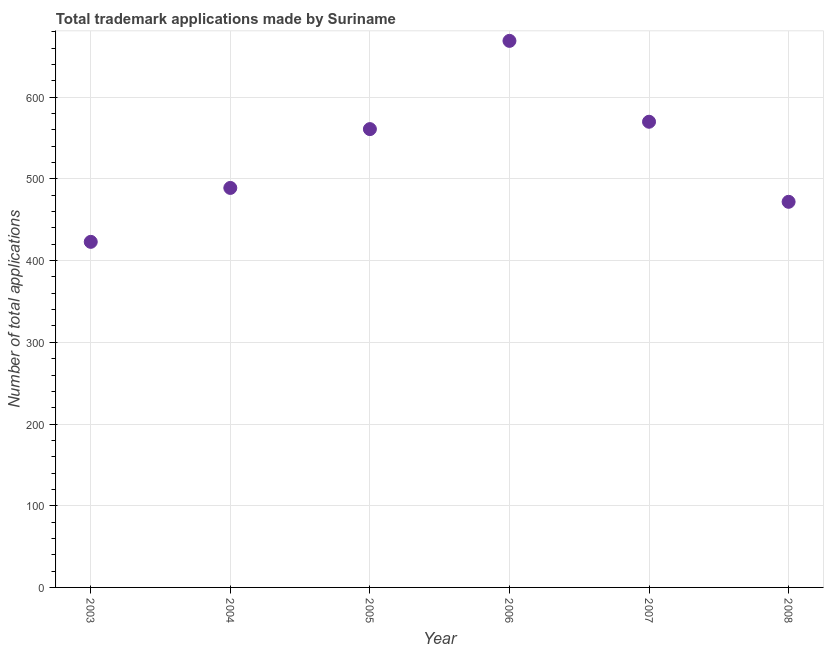What is the number of trademark applications in 2003?
Provide a succinct answer. 423. Across all years, what is the maximum number of trademark applications?
Provide a short and direct response. 669. Across all years, what is the minimum number of trademark applications?
Offer a very short reply. 423. In which year was the number of trademark applications minimum?
Give a very brief answer. 2003. What is the sum of the number of trademark applications?
Ensure brevity in your answer.  3184. What is the difference between the number of trademark applications in 2003 and 2004?
Ensure brevity in your answer.  -66. What is the average number of trademark applications per year?
Give a very brief answer. 530.67. What is the median number of trademark applications?
Provide a short and direct response. 525. What is the ratio of the number of trademark applications in 2003 to that in 2008?
Give a very brief answer. 0.9. What is the difference between the highest and the lowest number of trademark applications?
Your answer should be compact. 246. Does the number of trademark applications monotonically increase over the years?
Ensure brevity in your answer.  No. How many dotlines are there?
Make the answer very short. 1. What is the difference between two consecutive major ticks on the Y-axis?
Offer a very short reply. 100. Are the values on the major ticks of Y-axis written in scientific E-notation?
Offer a very short reply. No. Does the graph contain any zero values?
Give a very brief answer. No. Does the graph contain grids?
Offer a very short reply. Yes. What is the title of the graph?
Your answer should be very brief. Total trademark applications made by Suriname. What is the label or title of the X-axis?
Offer a terse response. Year. What is the label or title of the Y-axis?
Your answer should be compact. Number of total applications. What is the Number of total applications in 2003?
Your answer should be compact. 423. What is the Number of total applications in 2004?
Your answer should be very brief. 489. What is the Number of total applications in 2005?
Provide a short and direct response. 561. What is the Number of total applications in 2006?
Provide a succinct answer. 669. What is the Number of total applications in 2007?
Provide a succinct answer. 570. What is the Number of total applications in 2008?
Offer a terse response. 472. What is the difference between the Number of total applications in 2003 and 2004?
Provide a succinct answer. -66. What is the difference between the Number of total applications in 2003 and 2005?
Provide a short and direct response. -138. What is the difference between the Number of total applications in 2003 and 2006?
Ensure brevity in your answer.  -246. What is the difference between the Number of total applications in 2003 and 2007?
Your response must be concise. -147. What is the difference between the Number of total applications in 2003 and 2008?
Make the answer very short. -49. What is the difference between the Number of total applications in 2004 and 2005?
Offer a terse response. -72. What is the difference between the Number of total applications in 2004 and 2006?
Provide a succinct answer. -180. What is the difference between the Number of total applications in 2004 and 2007?
Your answer should be compact. -81. What is the difference between the Number of total applications in 2004 and 2008?
Ensure brevity in your answer.  17. What is the difference between the Number of total applications in 2005 and 2006?
Make the answer very short. -108. What is the difference between the Number of total applications in 2005 and 2008?
Ensure brevity in your answer.  89. What is the difference between the Number of total applications in 2006 and 2008?
Your answer should be compact. 197. What is the difference between the Number of total applications in 2007 and 2008?
Give a very brief answer. 98. What is the ratio of the Number of total applications in 2003 to that in 2004?
Your response must be concise. 0.86. What is the ratio of the Number of total applications in 2003 to that in 2005?
Your response must be concise. 0.75. What is the ratio of the Number of total applications in 2003 to that in 2006?
Offer a terse response. 0.63. What is the ratio of the Number of total applications in 2003 to that in 2007?
Your answer should be very brief. 0.74. What is the ratio of the Number of total applications in 2003 to that in 2008?
Make the answer very short. 0.9. What is the ratio of the Number of total applications in 2004 to that in 2005?
Ensure brevity in your answer.  0.87. What is the ratio of the Number of total applications in 2004 to that in 2006?
Your response must be concise. 0.73. What is the ratio of the Number of total applications in 2004 to that in 2007?
Keep it short and to the point. 0.86. What is the ratio of the Number of total applications in 2004 to that in 2008?
Your answer should be compact. 1.04. What is the ratio of the Number of total applications in 2005 to that in 2006?
Provide a short and direct response. 0.84. What is the ratio of the Number of total applications in 2005 to that in 2008?
Your answer should be compact. 1.19. What is the ratio of the Number of total applications in 2006 to that in 2007?
Your response must be concise. 1.17. What is the ratio of the Number of total applications in 2006 to that in 2008?
Give a very brief answer. 1.42. What is the ratio of the Number of total applications in 2007 to that in 2008?
Offer a very short reply. 1.21. 